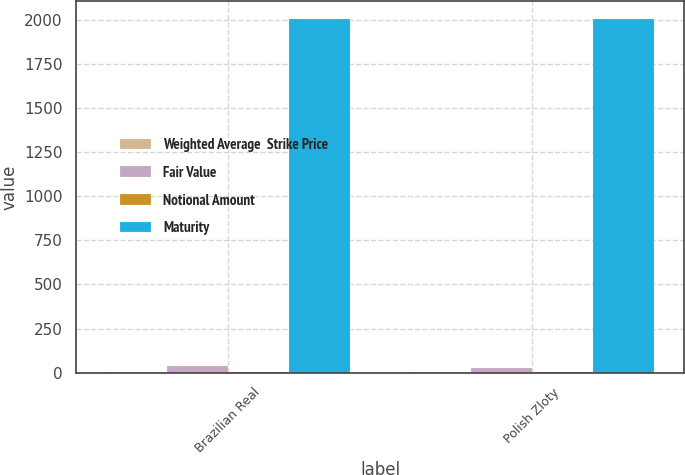Convert chart. <chart><loc_0><loc_0><loc_500><loc_500><stacked_bar_chart><ecel><fcel>Brazilian Real<fcel>Polish Zloty<nl><fcel>Weighted Average  Strike Price<fcel>2.78<fcel>3.57<nl><fcel>Fair Value<fcel>38<fcel>25<nl><fcel>Notional Amount<fcel>4<fcel>2<nl><fcel>Maturity<fcel>2006<fcel>2006<nl></chart> 